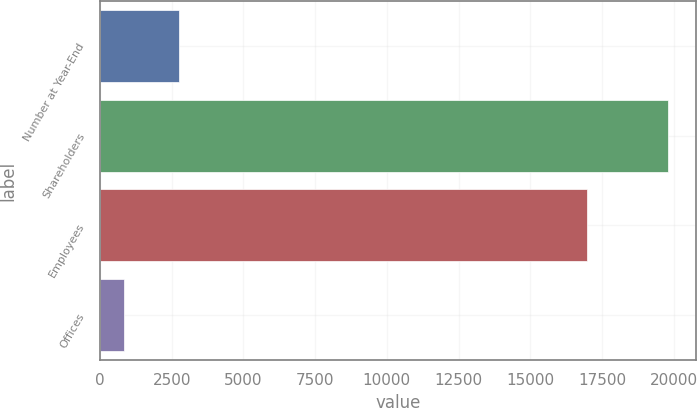Convert chart to OTSL. <chart><loc_0><loc_0><loc_500><loc_500><bar_chart><fcel>Number at Year-End<fcel>Shareholders<fcel>Employees<fcel>Offices<nl><fcel>2749.7<fcel>19802<fcel>16973<fcel>855<nl></chart> 